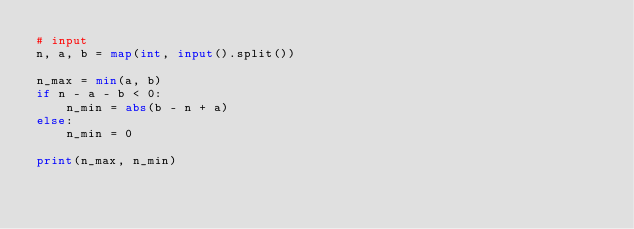<code> <loc_0><loc_0><loc_500><loc_500><_Python_># input
n, a, b = map(int, input().split())

n_max = min(a, b)
if n - a - b < 0:
    n_min = abs(b - n + a)
else:
    n_min = 0

print(n_max, n_min)</code> 